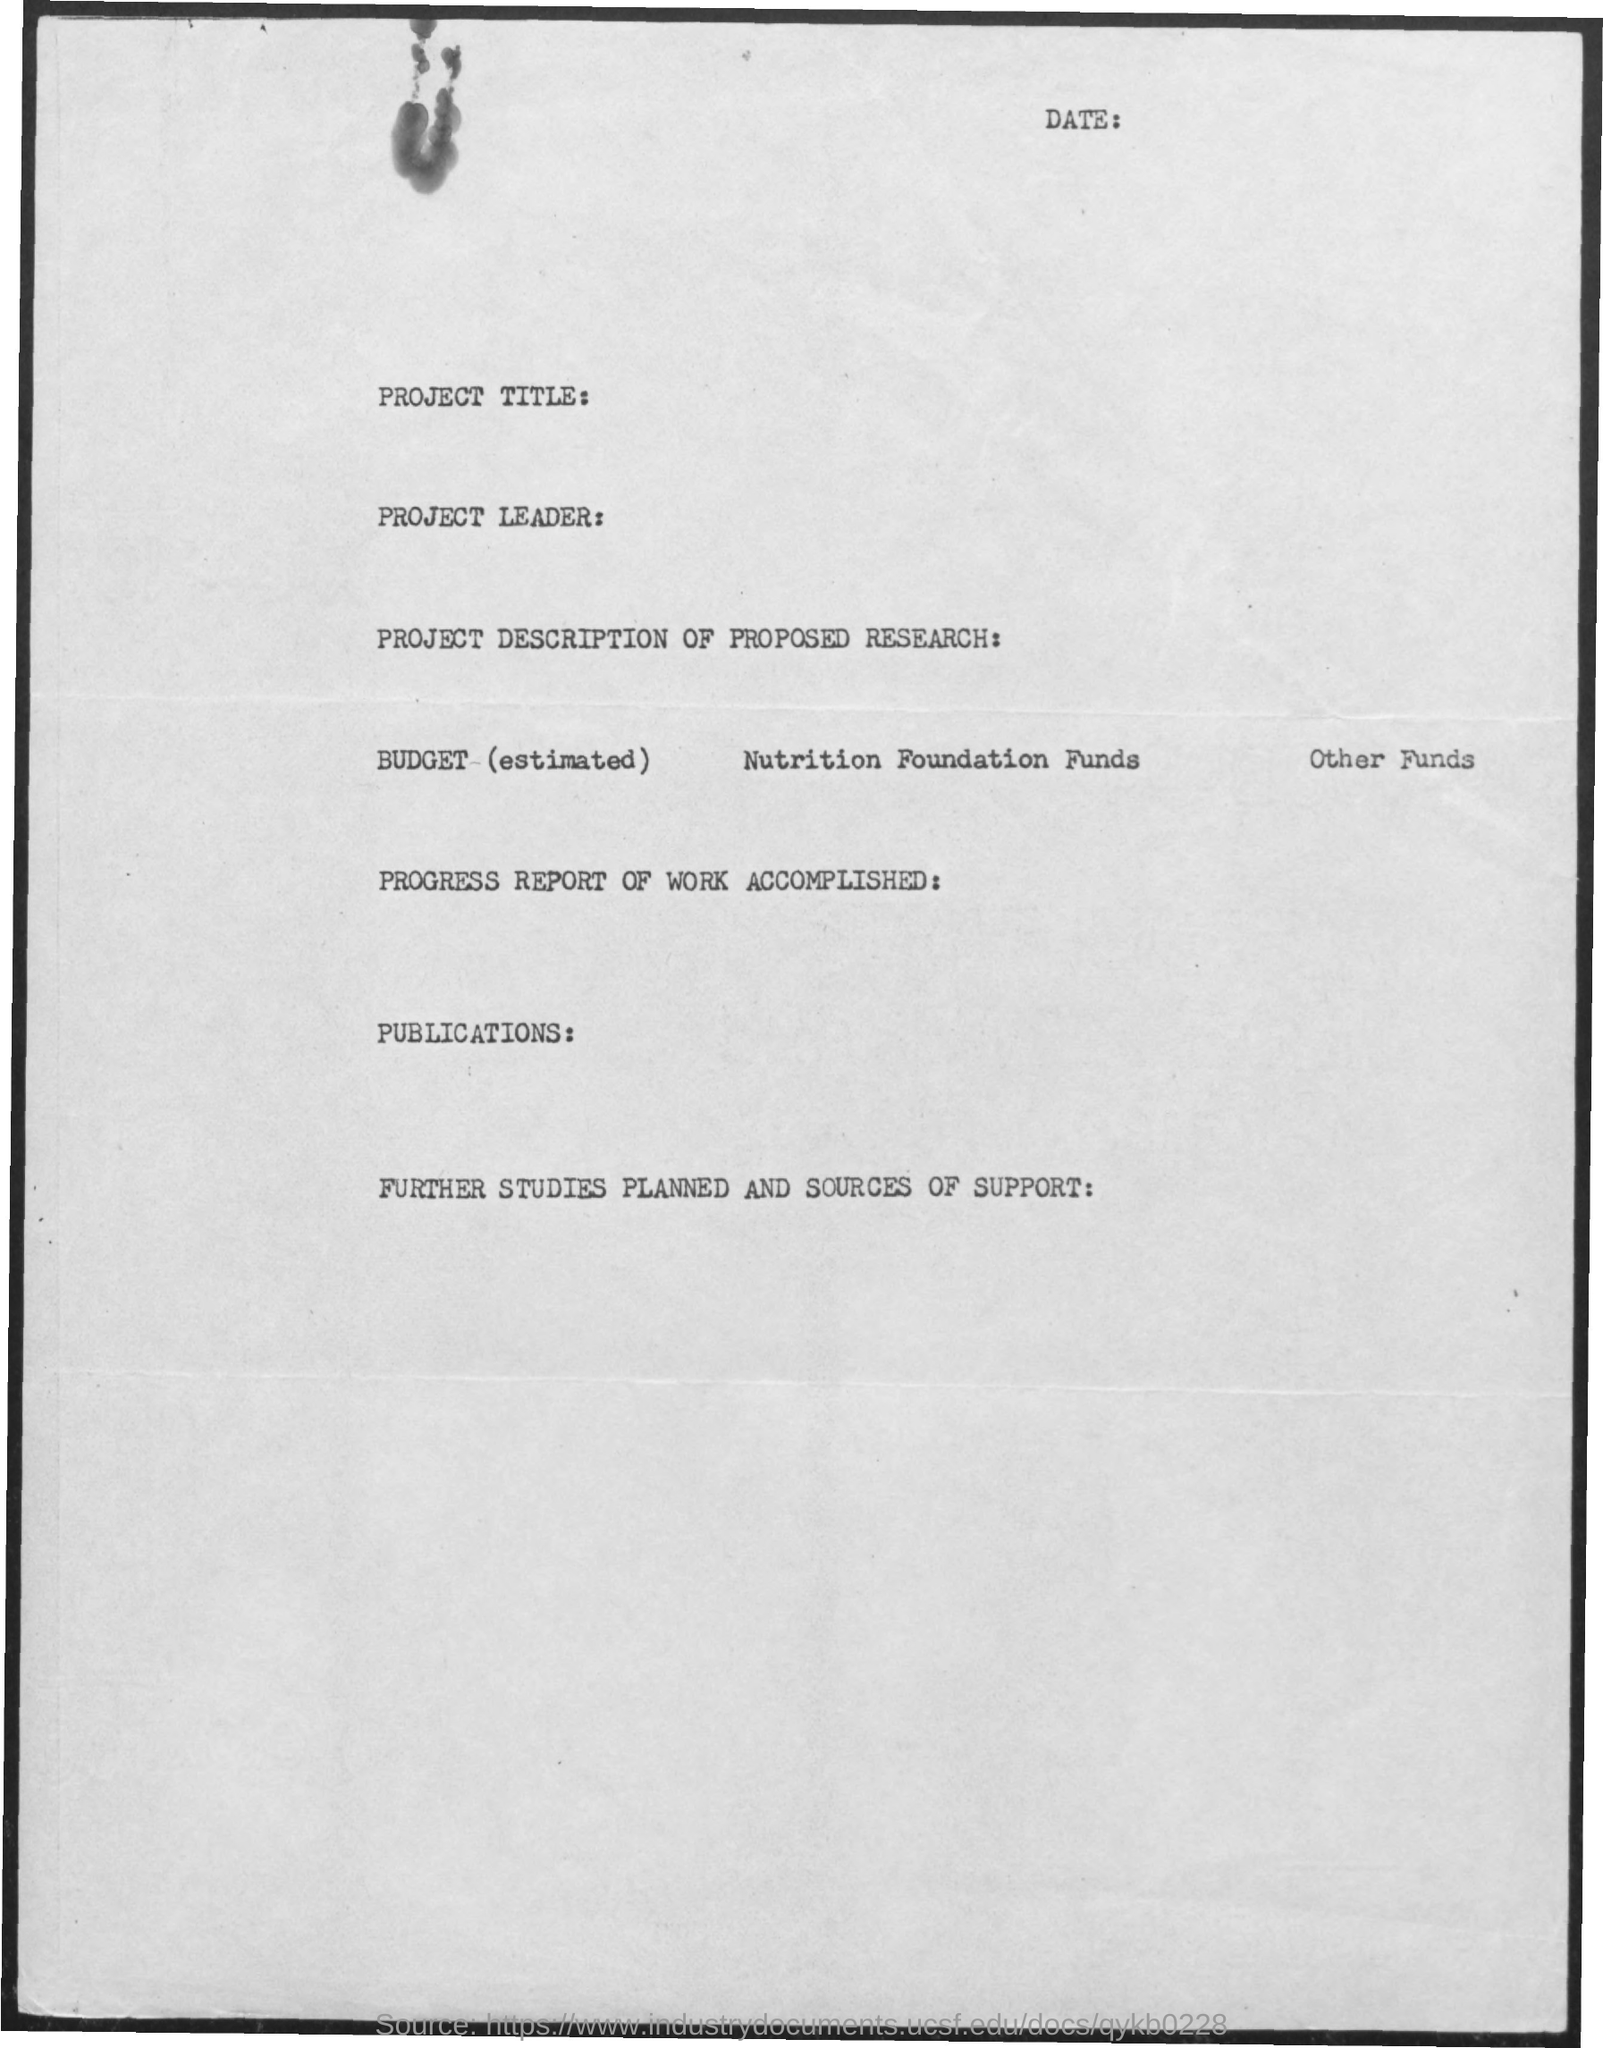List a handful of essential elements in this visual. The text written at the top is a declaration, which provides information about the date. 